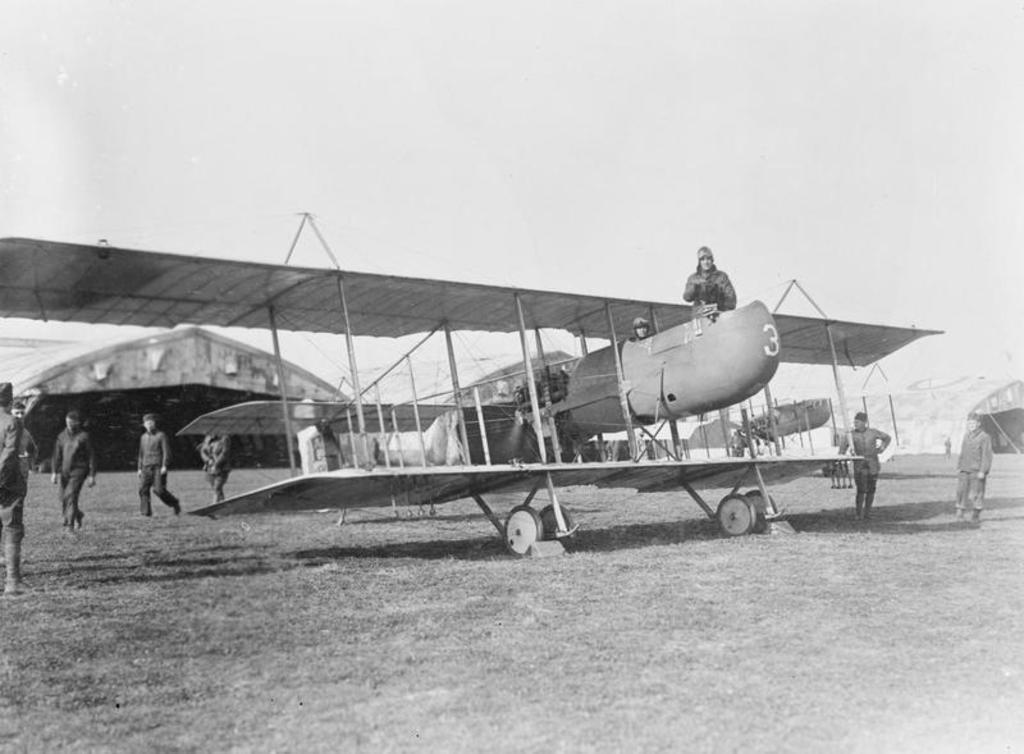Can you describe this image briefly? In this image there is an aircraft and there are persons on the ground and there are persons in the aircraft. In the background there are tents. 